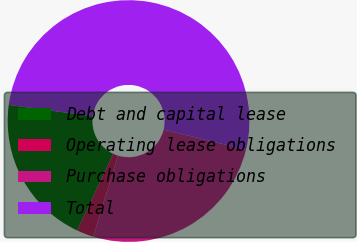<chart> <loc_0><loc_0><loc_500><loc_500><pie_chart><fcel>Debt and capital lease<fcel>Operating lease obligations<fcel>Purchase obligations<fcel>Total<nl><fcel>20.15%<fcel>2.26%<fcel>25.92%<fcel>51.67%<nl></chart> 